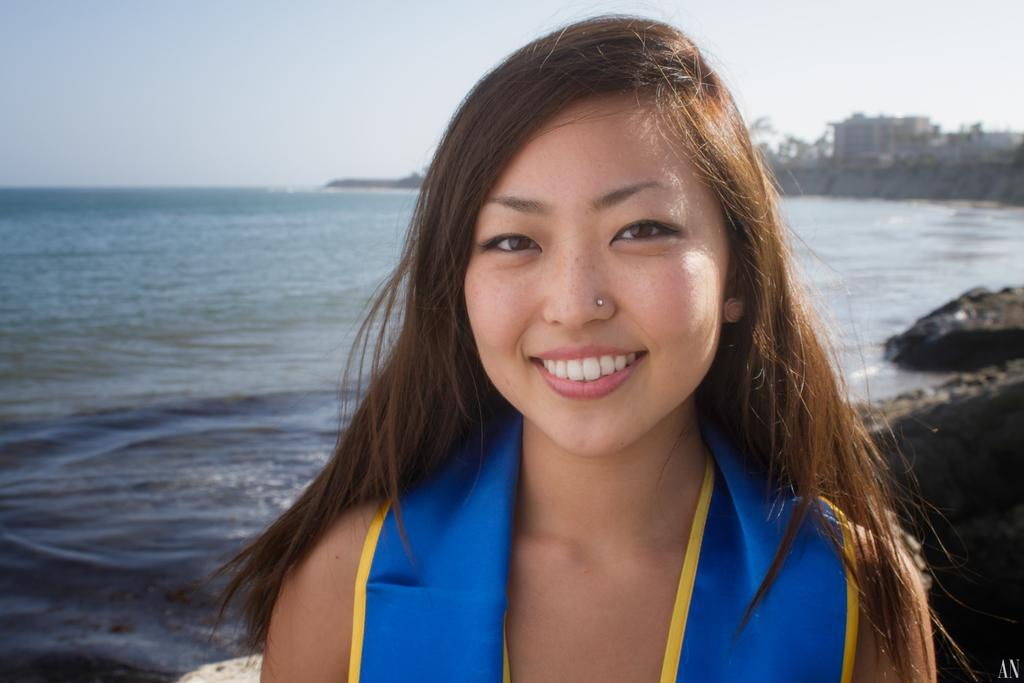Who is present in the image? There is a woman in the image. What natural feature can be seen in the image? There is a sea in the image. What type of landscape elements are present in the image? There are rocks and trees in the image. What man-made structures can be seen in the image? There are buildings in the image. What is visible in the background of the image? The sky is visible in the background of the image. What type of soda is the woman drinking in the image? There is no soda present in the image, and the woman is not shown drinking anything. What body part is the woman using to show her excitement in the image? The image does not depict the woman expressing excitement or using any body part to do so. 